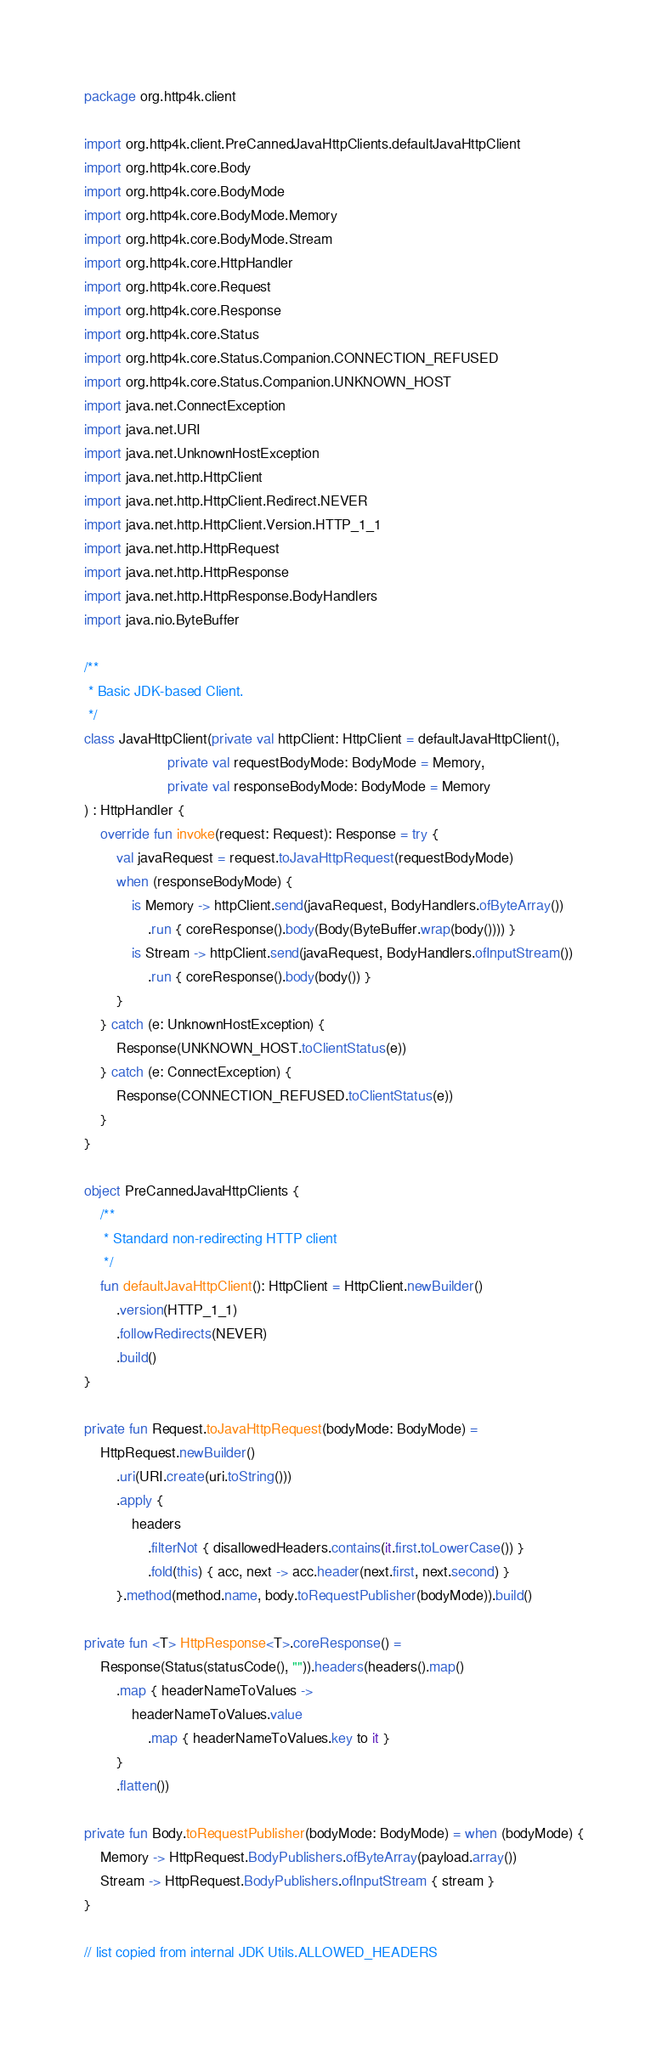Convert code to text. <code><loc_0><loc_0><loc_500><loc_500><_Kotlin_>package org.http4k.client

import org.http4k.client.PreCannedJavaHttpClients.defaultJavaHttpClient
import org.http4k.core.Body
import org.http4k.core.BodyMode
import org.http4k.core.BodyMode.Memory
import org.http4k.core.BodyMode.Stream
import org.http4k.core.HttpHandler
import org.http4k.core.Request
import org.http4k.core.Response
import org.http4k.core.Status
import org.http4k.core.Status.Companion.CONNECTION_REFUSED
import org.http4k.core.Status.Companion.UNKNOWN_HOST
import java.net.ConnectException
import java.net.URI
import java.net.UnknownHostException
import java.net.http.HttpClient
import java.net.http.HttpClient.Redirect.NEVER
import java.net.http.HttpClient.Version.HTTP_1_1
import java.net.http.HttpRequest
import java.net.http.HttpResponse
import java.net.http.HttpResponse.BodyHandlers
import java.nio.ByteBuffer

/**
 * Basic JDK-based Client.
 */
class JavaHttpClient(private val httpClient: HttpClient = defaultJavaHttpClient(),
                     private val requestBodyMode: BodyMode = Memory,
                     private val responseBodyMode: BodyMode = Memory
) : HttpHandler {
    override fun invoke(request: Request): Response = try {
        val javaRequest = request.toJavaHttpRequest(requestBodyMode)
        when (responseBodyMode) {
            is Memory -> httpClient.send(javaRequest, BodyHandlers.ofByteArray())
                .run { coreResponse().body(Body(ByteBuffer.wrap(body()))) }
            is Stream -> httpClient.send(javaRequest, BodyHandlers.ofInputStream())
                .run { coreResponse().body(body()) }
        }
    } catch (e: UnknownHostException) {
        Response(UNKNOWN_HOST.toClientStatus(e))
    } catch (e: ConnectException) {
        Response(CONNECTION_REFUSED.toClientStatus(e))
    }
}

object PreCannedJavaHttpClients {
    /**
     * Standard non-redirecting HTTP client
     */
    fun defaultJavaHttpClient(): HttpClient = HttpClient.newBuilder()
        .version(HTTP_1_1)
        .followRedirects(NEVER)
        .build()
}

private fun Request.toJavaHttpRequest(bodyMode: BodyMode) =
    HttpRequest.newBuilder()
        .uri(URI.create(uri.toString()))
        .apply {
            headers
                .filterNot { disallowedHeaders.contains(it.first.toLowerCase()) }
                .fold(this) { acc, next -> acc.header(next.first, next.second) }
        }.method(method.name, body.toRequestPublisher(bodyMode)).build()

private fun <T> HttpResponse<T>.coreResponse() =
    Response(Status(statusCode(), "")).headers(headers().map()
        .map { headerNameToValues ->
            headerNameToValues.value
                .map { headerNameToValues.key to it }
        }
        .flatten())

private fun Body.toRequestPublisher(bodyMode: BodyMode) = when (bodyMode) {
    Memory -> HttpRequest.BodyPublishers.ofByteArray(payload.array())
    Stream -> HttpRequest.BodyPublishers.ofInputStream { stream }
}

// list copied from internal JDK Utils.ALLOWED_HEADERS</code> 